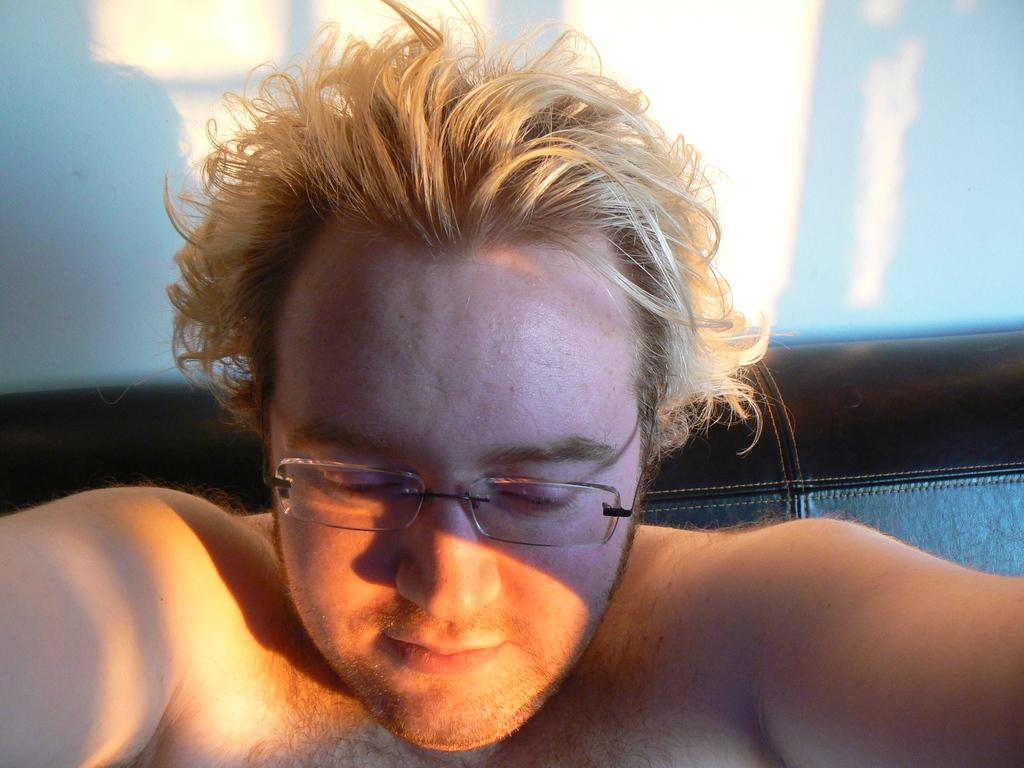Who is present in the image? There is a man in the image. What accessory is the man wearing? The man is wearing glasses (specs). What can be seen in the background of the image? There is a wall in the background of the image. What is the committee's decision regarding the man's glasses in the image? There is no committee present in the image, and therefore no decision can be made about the man's glasses. 